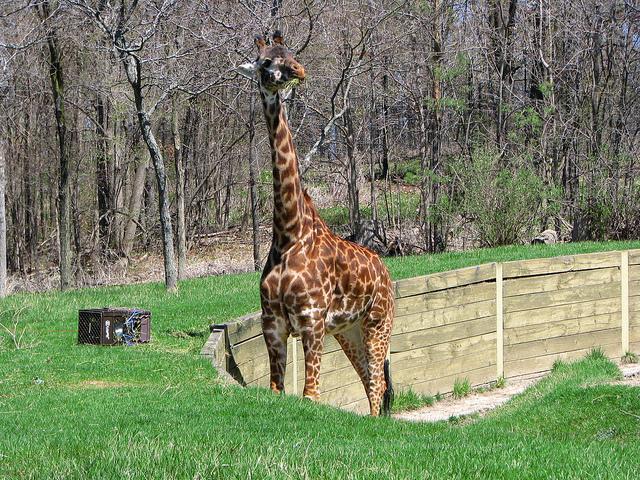How many animals are shown?
Give a very brief answer. 1. 